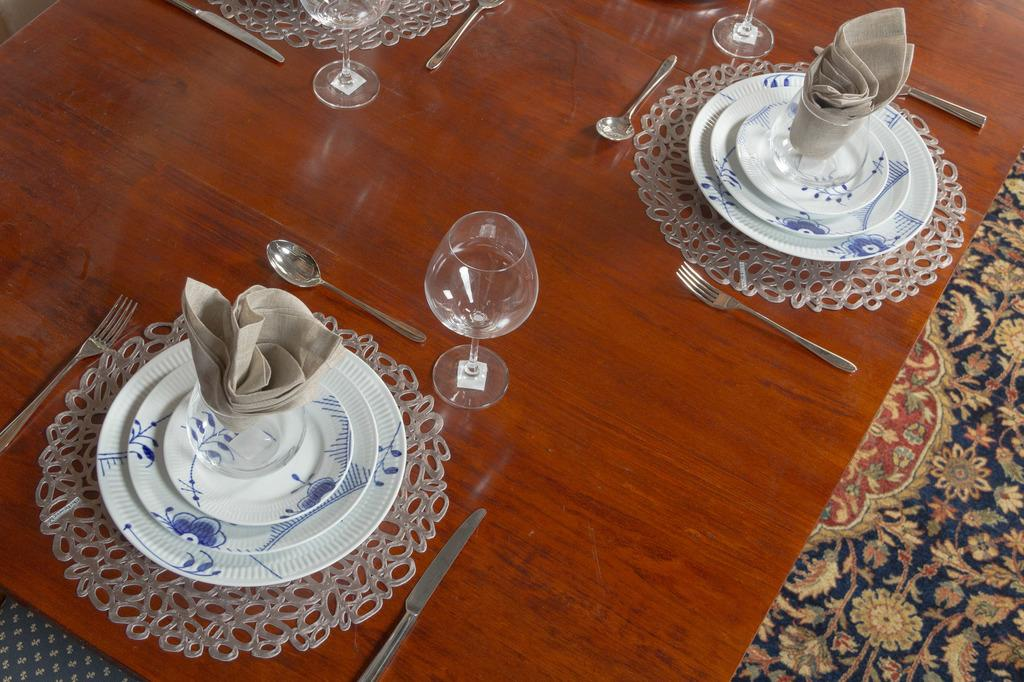What type of object is on the floor in the image? There is a floor mat in the image. What piece of furniture is present in the image? There is a table in the image. What utensils can be seen in the image? There is a knife, a spoon, and a fork in the image. What is placed on the table in the image? There is a table mat, plates, and a glass in the image. What accessory is visible in the image? There is a kerchief in the image. What type of advice is the pig giving to the comb in the image? There is no pig, comb, or advice present in the image. 